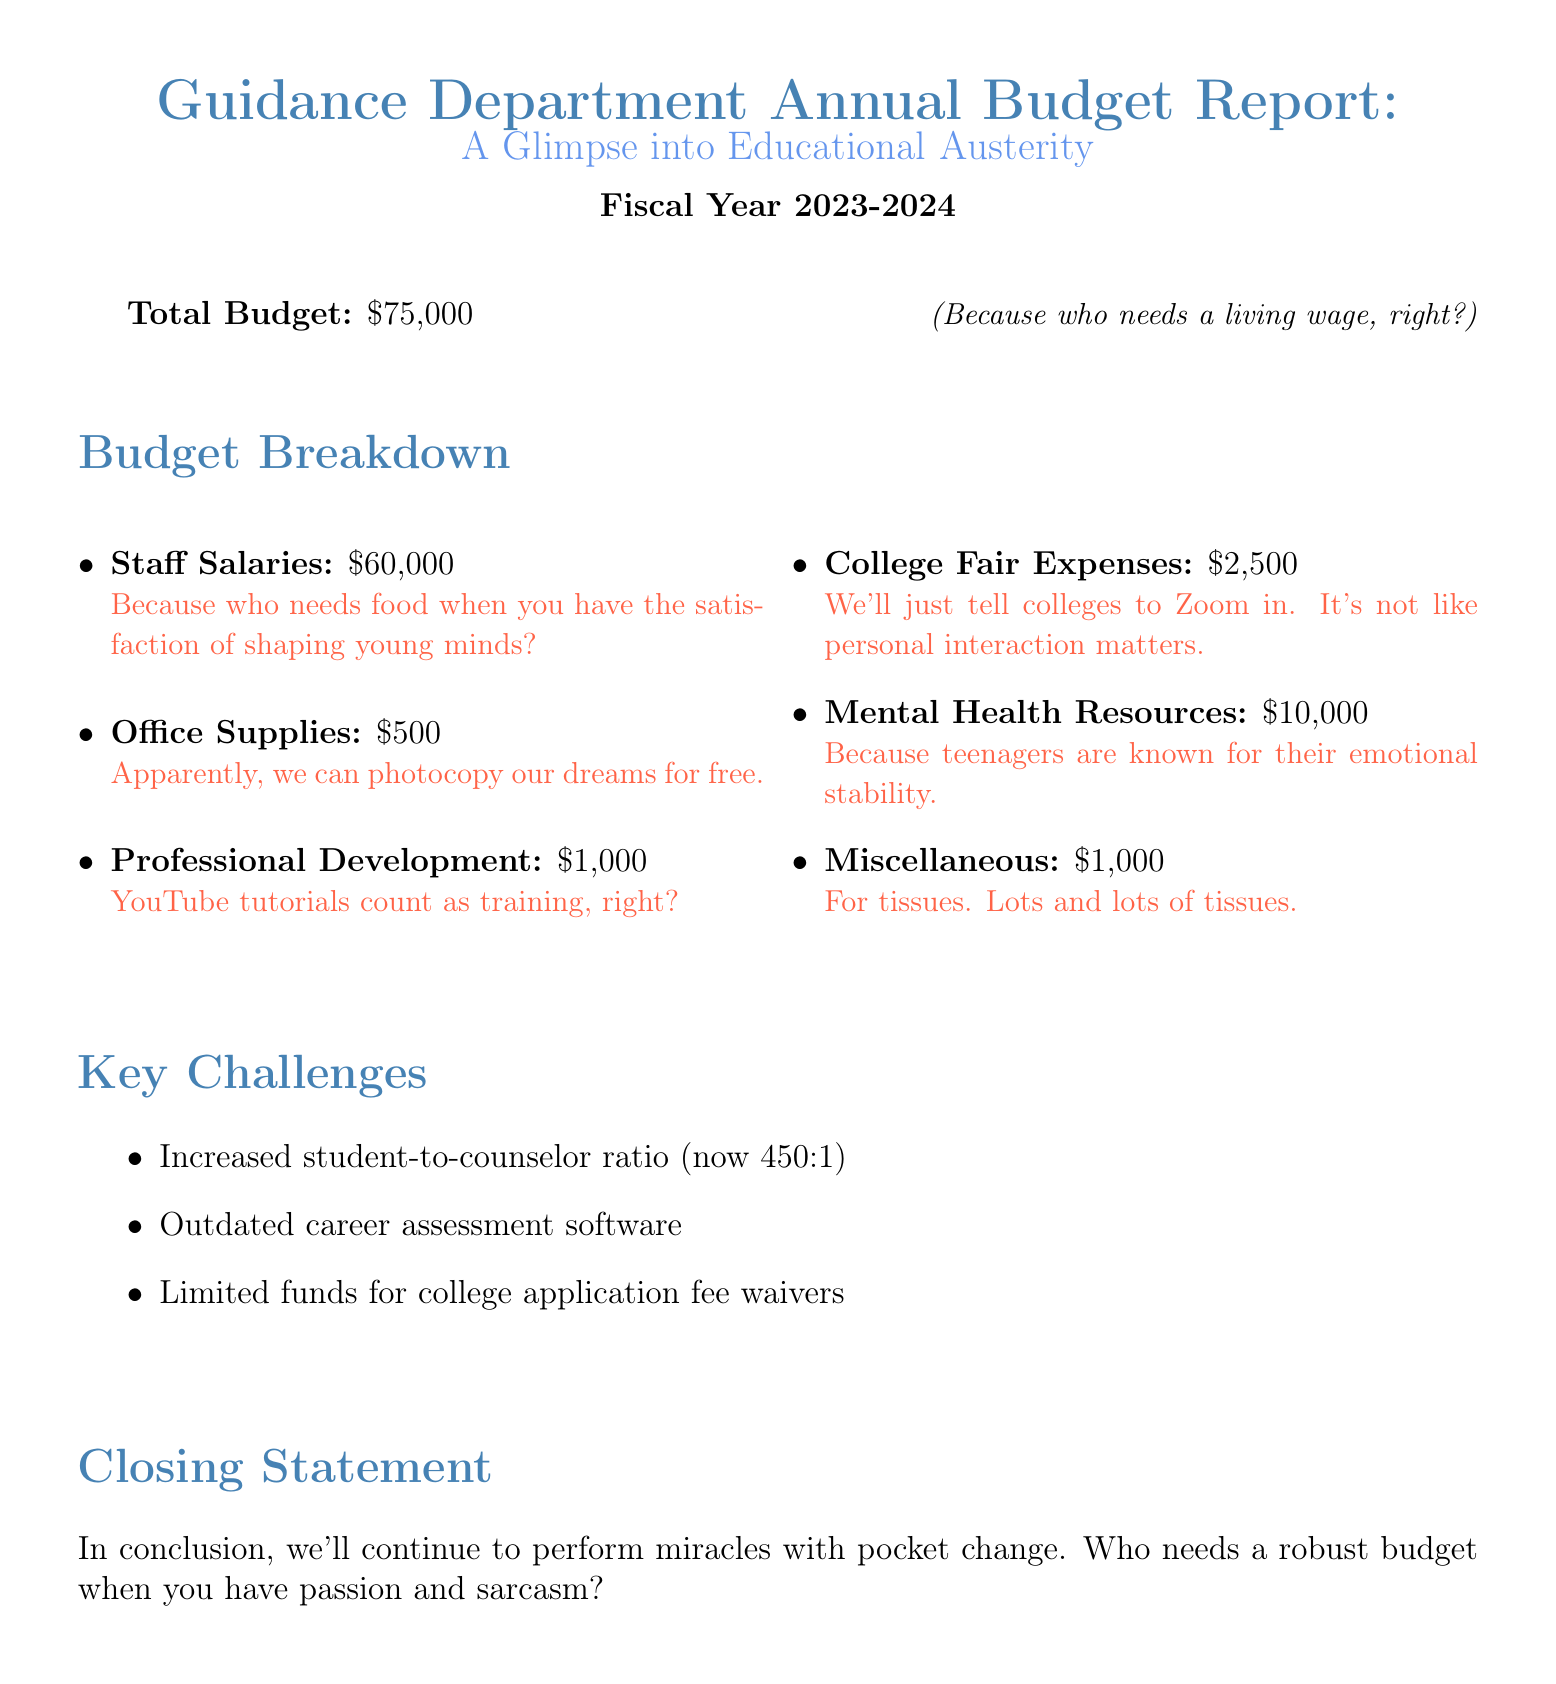What is the total budget? The total budget for the Guidance Department in the fiscal year 2023-2024 is stated directly in the document.
Answer: $75,000 How much is allocated for staff salaries? The budget breakdown specifies the amount allocated for staff salaries.
Answer: $60,000 What is the amount for office supplies? The report lists the budget for office supplies, which is explicitly mentioned.
Answer: $500 What is the student-to-counselor ratio? The report outlines a key challenge related to the student-to-counselor ratio.
Answer: 450:1 How much is designated for professional development? This amount is found in the budget breakdown, under the relevant category.
Answer: $1,000 What is the stated closing statement? The closing statement of the document summarizes the overall sentiment expressed within it.
Answer: In conclusion, we'll continue to perform miracles with pocket change. Who needs a robust budget when you have passion and sarcasm? What are the key challenges mentioned? The document lists specific key challenges faced by the Guidance Department, which are addressed directly.
Answer: Increased student-to-counselor ratio, Outdated career assessment software, Limited funds for college application fee waivers What is the budget amount for mental health resources? This amount is part of the budget breakdown and shows the allocated funds for mental health resources.
Answer: $10,000 How much is allocated for college fair expenses? The budget breakdown includes the designated amount for college fair expenses.
Answer: $2,500 